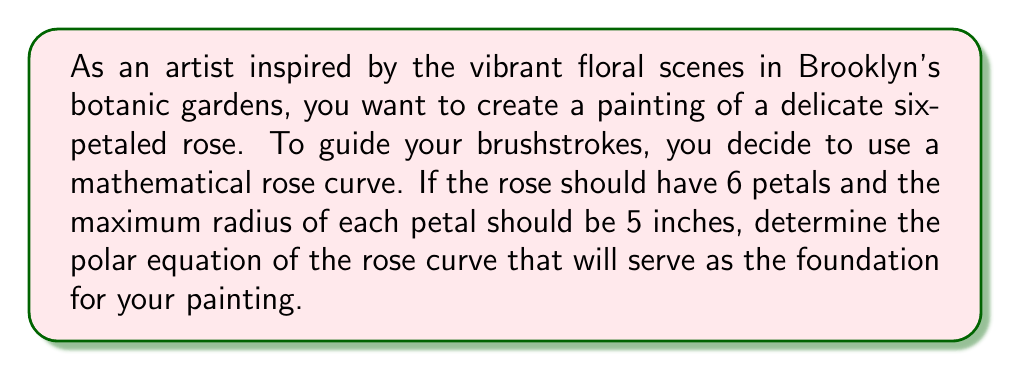What is the answer to this math problem? To determine the equation of a rose curve with 6 petals, we need to follow these steps:

1. The general equation for a rose curve is:
   $$ r = a \cos(n\theta) \quad \text{or} \quad r = a \sin(n\theta) $$
   where $a$ is the maximum radius and $n$ determines the number of petals.

2. For a rose with an even number of petals, we use the cosine function. Since we want 6 petals, our equation will be of the form:
   $$ r = a \cos(3\theta) $$

3. The number of petals is determined by the value inside the cosine function. For $k$ petals:
   - If $k$ is even, use $n = k/2$
   - If $k$ is odd, use $n = k$

   In this case, $k = 6$ (even), so $n = 6/2 = 3$

4. We're given that the maximum radius of each petal should be 5 inches. In a rose curve, this corresponds to the value of $a$. Therefore, $a = 5$.

5. Substituting these values into our equation:
   $$ r = 5 \cos(3\theta) $$

This equation will produce a six-petaled rose curve with a maximum radius of 5 inches for each petal, perfect for guiding your painting strokes.

[asy]
import graph;
size(200);
real r(real t) {return 5*cos(3*t);}
draw(polargraph(r,0,2*pi,operator ..),blue);
draw(circle((0,0),5),dashed);
label("5 inches",(-2.5,-4.3),E);
[/asy]
Answer: $$ r = 5 \cos(3\theta) $$ 